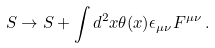<formula> <loc_0><loc_0><loc_500><loc_500>S \rightarrow S + \int d ^ { 2 } x \theta ( x ) \epsilon _ { \mu \nu } F ^ { \mu \nu } \, .</formula> 